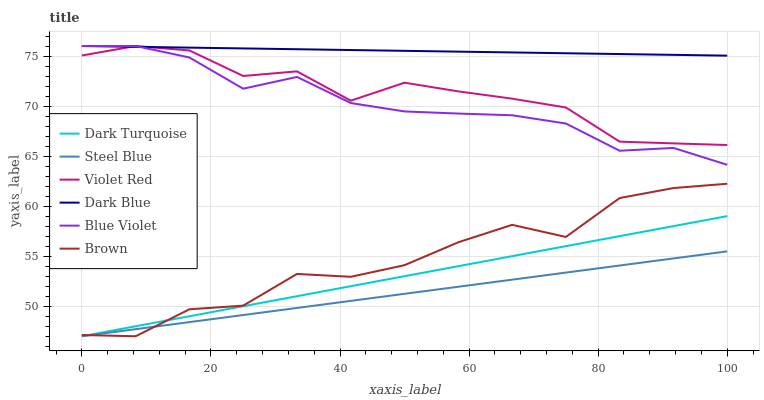Does Steel Blue have the minimum area under the curve?
Answer yes or no. Yes. Does Dark Blue have the maximum area under the curve?
Answer yes or no. Yes. Does Violet Red have the minimum area under the curve?
Answer yes or no. No. Does Violet Red have the maximum area under the curve?
Answer yes or no. No. Is Steel Blue the smoothest?
Answer yes or no. Yes. Is Brown the roughest?
Answer yes or no. Yes. Is Violet Red the smoothest?
Answer yes or no. No. Is Violet Red the roughest?
Answer yes or no. No. Does Brown have the lowest value?
Answer yes or no. Yes. Does Violet Red have the lowest value?
Answer yes or no. No. Does Blue Violet have the highest value?
Answer yes or no. Yes. Does Dark Turquoise have the highest value?
Answer yes or no. No. Is Steel Blue less than Blue Violet?
Answer yes or no. Yes. Is Blue Violet greater than Dark Turquoise?
Answer yes or no. Yes. Does Brown intersect Dark Turquoise?
Answer yes or no. Yes. Is Brown less than Dark Turquoise?
Answer yes or no. No. Is Brown greater than Dark Turquoise?
Answer yes or no. No. Does Steel Blue intersect Blue Violet?
Answer yes or no. No. 